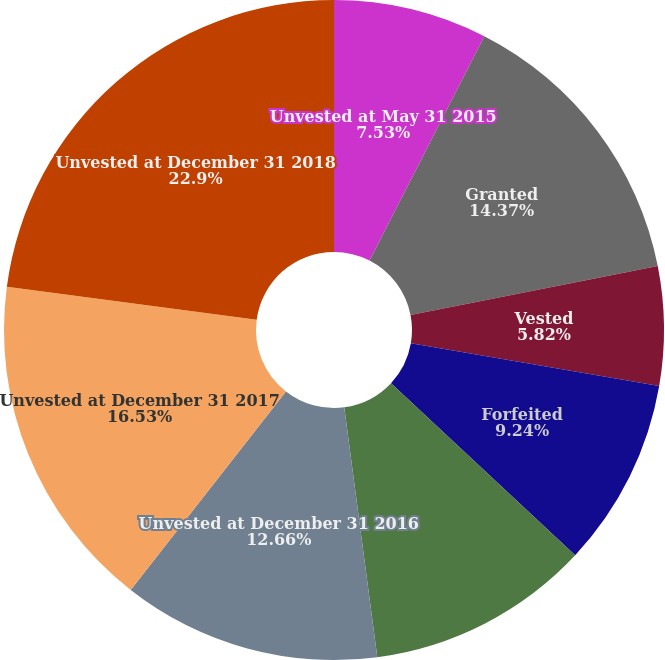<chart> <loc_0><loc_0><loc_500><loc_500><pie_chart><fcel>Unvested at May 31 2015<fcel>Granted<fcel>Vested<fcel>Forfeited<fcel>Unvested at May 31 2016<fcel>Unvested at December 31 2016<fcel>Unvested at December 31 2017<fcel>Unvested at December 31 2018<nl><fcel>7.53%<fcel>14.37%<fcel>5.82%<fcel>9.24%<fcel>10.95%<fcel>12.66%<fcel>16.53%<fcel>22.91%<nl></chart> 